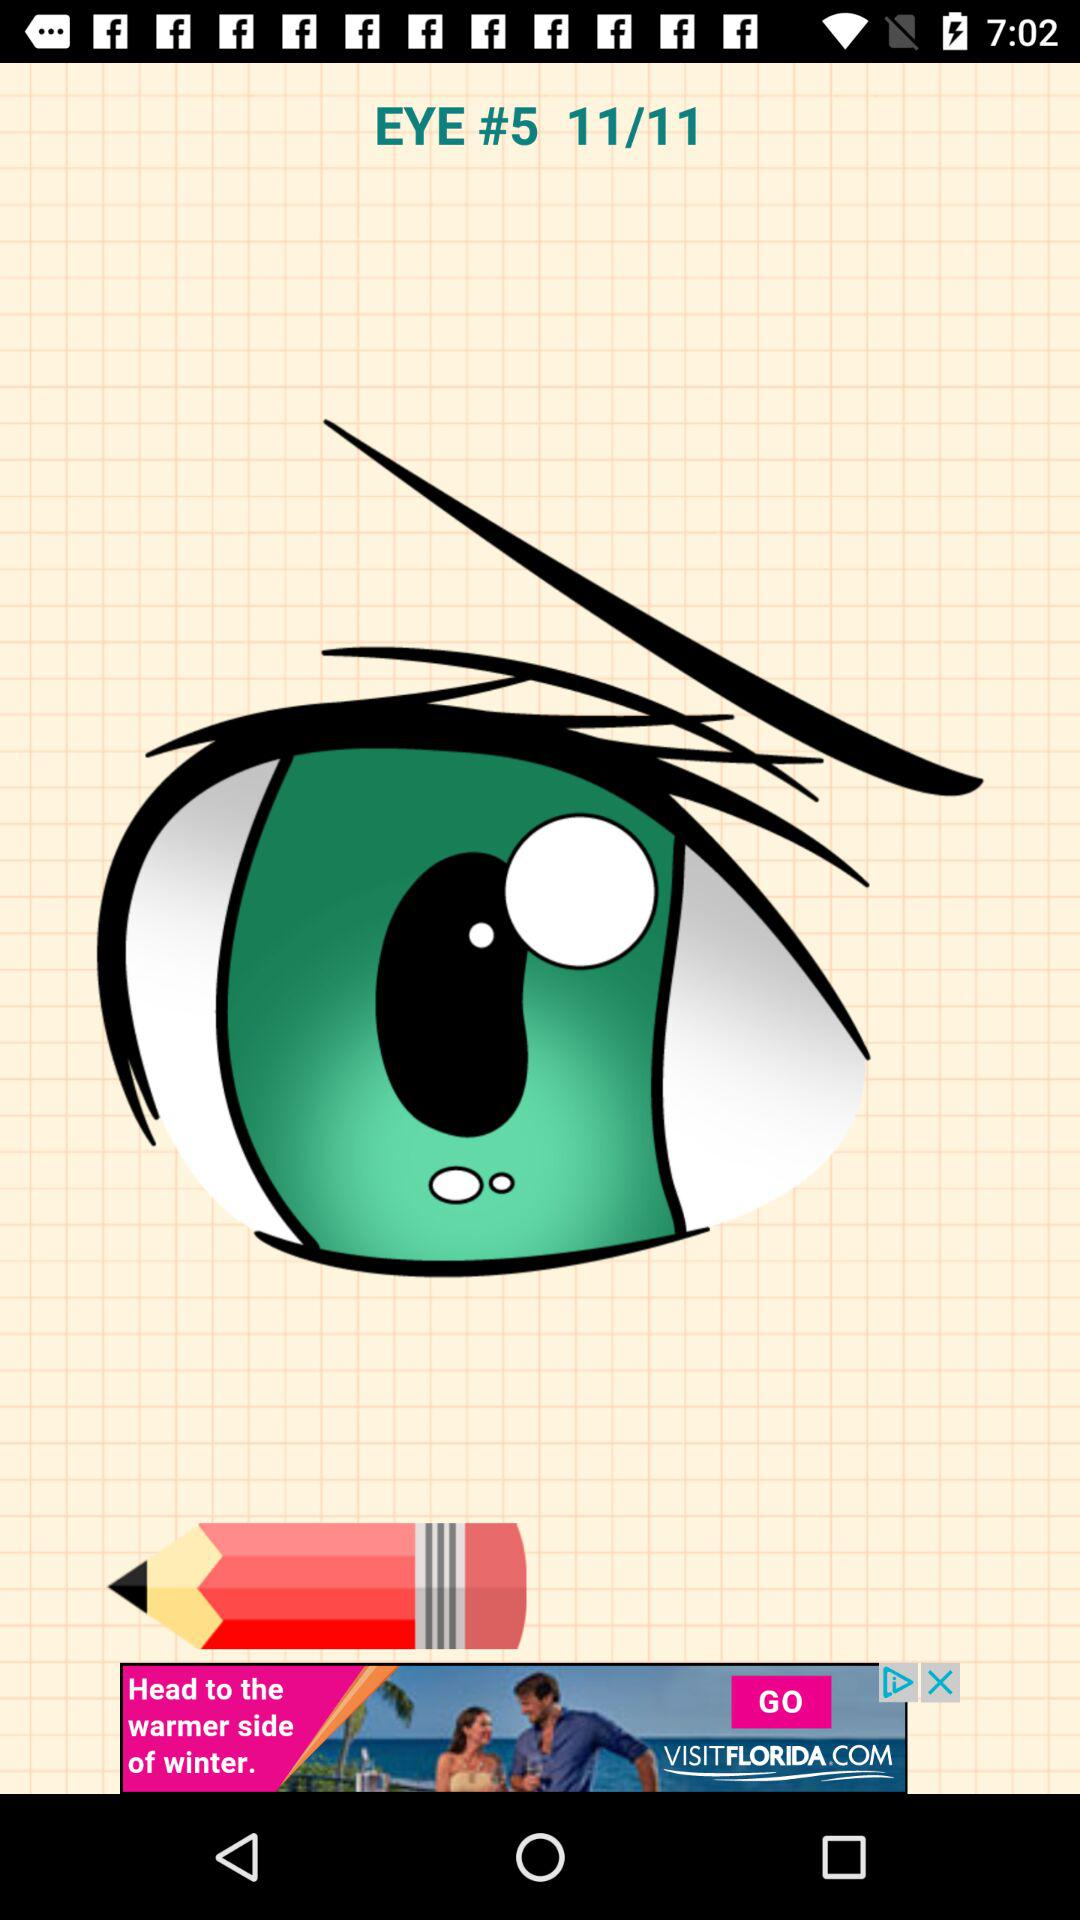What is the title of image 10?
When the provided information is insufficient, respond with <no answer>. <no answer> 